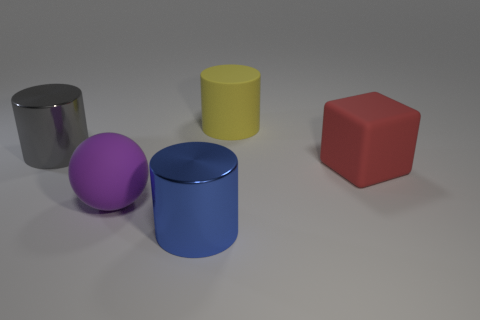Are there any other things that are the same shape as the big gray object?
Make the answer very short. Yes. There is a metallic object right of the large rubber object to the left of the big yellow rubber cylinder; how big is it?
Ensure brevity in your answer.  Large. How many tiny things are green shiny cubes or blue shiny cylinders?
Make the answer very short. 0. Is the number of blue things less than the number of small matte cylinders?
Your answer should be compact. No. Are there more cyan matte spheres than gray metal things?
Your answer should be compact. No. How many other things are there of the same color as the big matte ball?
Provide a succinct answer. 0. There is a large thing in front of the matte ball; what number of red objects are in front of it?
Your response must be concise. 0. Are there any large yellow matte objects behind the large rubber cylinder?
Make the answer very short. No. The big shiny thing that is to the right of the big cylinder to the left of the rubber ball is what shape?
Keep it short and to the point. Cylinder. Is the number of big gray objects that are left of the large red matte object less than the number of rubber objects that are in front of the large gray metal thing?
Ensure brevity in your answer.  Yes. 